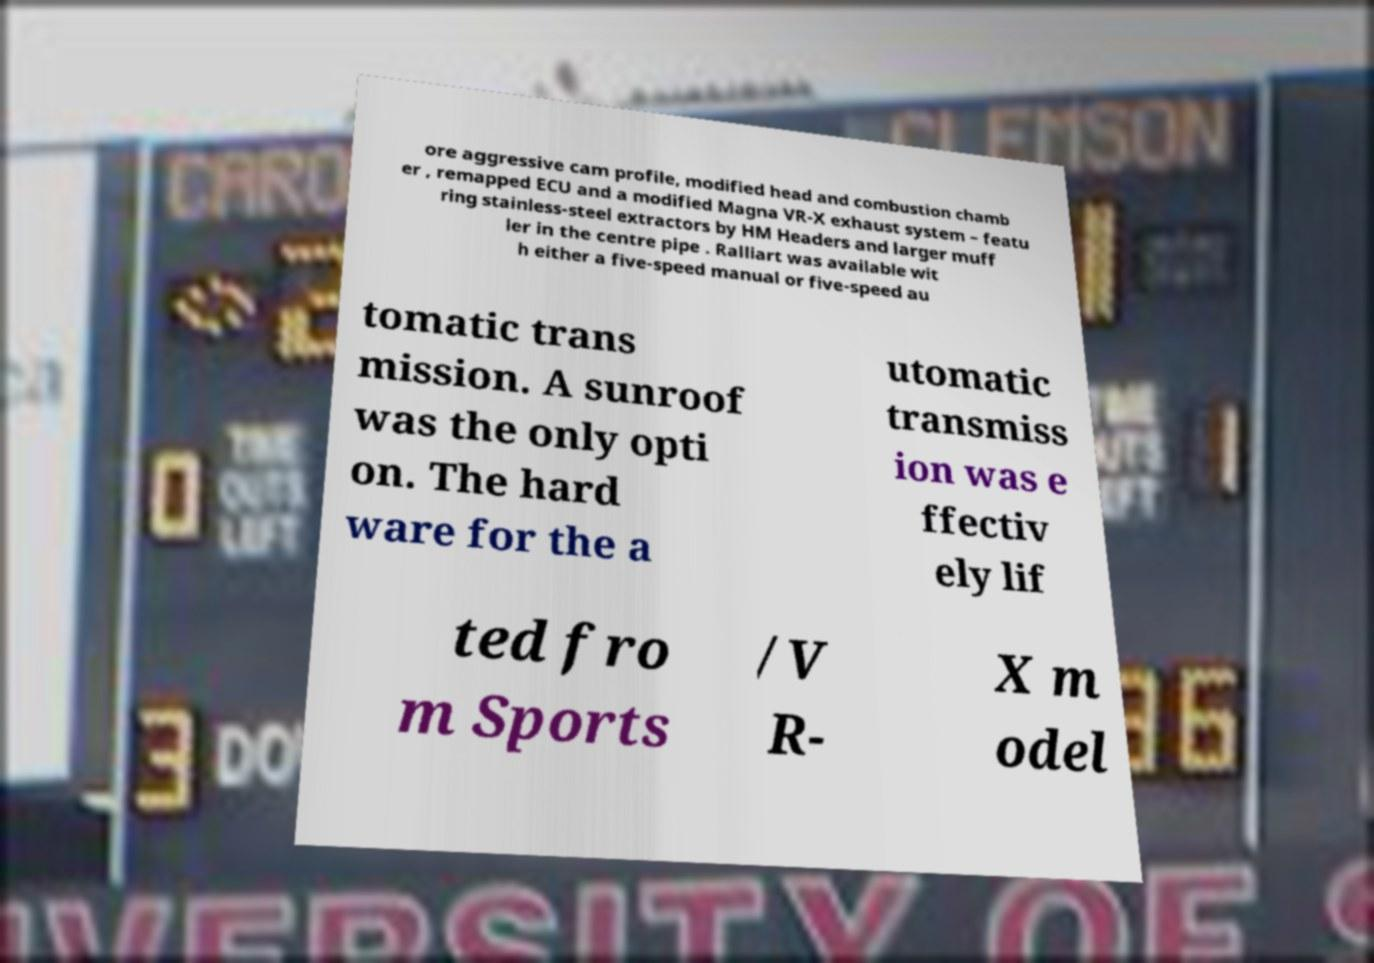Please identify and transcribe the text found in this image. ore aggressive cam profile, modified head and combustion chamb er , remapped ECU and a modified Magna VR-X exhaust system – featu ring stainless-steel extractors by HM Headers and larger muff ler in the centre pipe . Ralliart was available wit h either a five-speed manual or five-speed au tomatic trans mission. A sunroof was the only opti on. The hard ware for the a utomatic transmiss ion was e ffectiv ely lif ted fro m Sports /V R- X m odel 